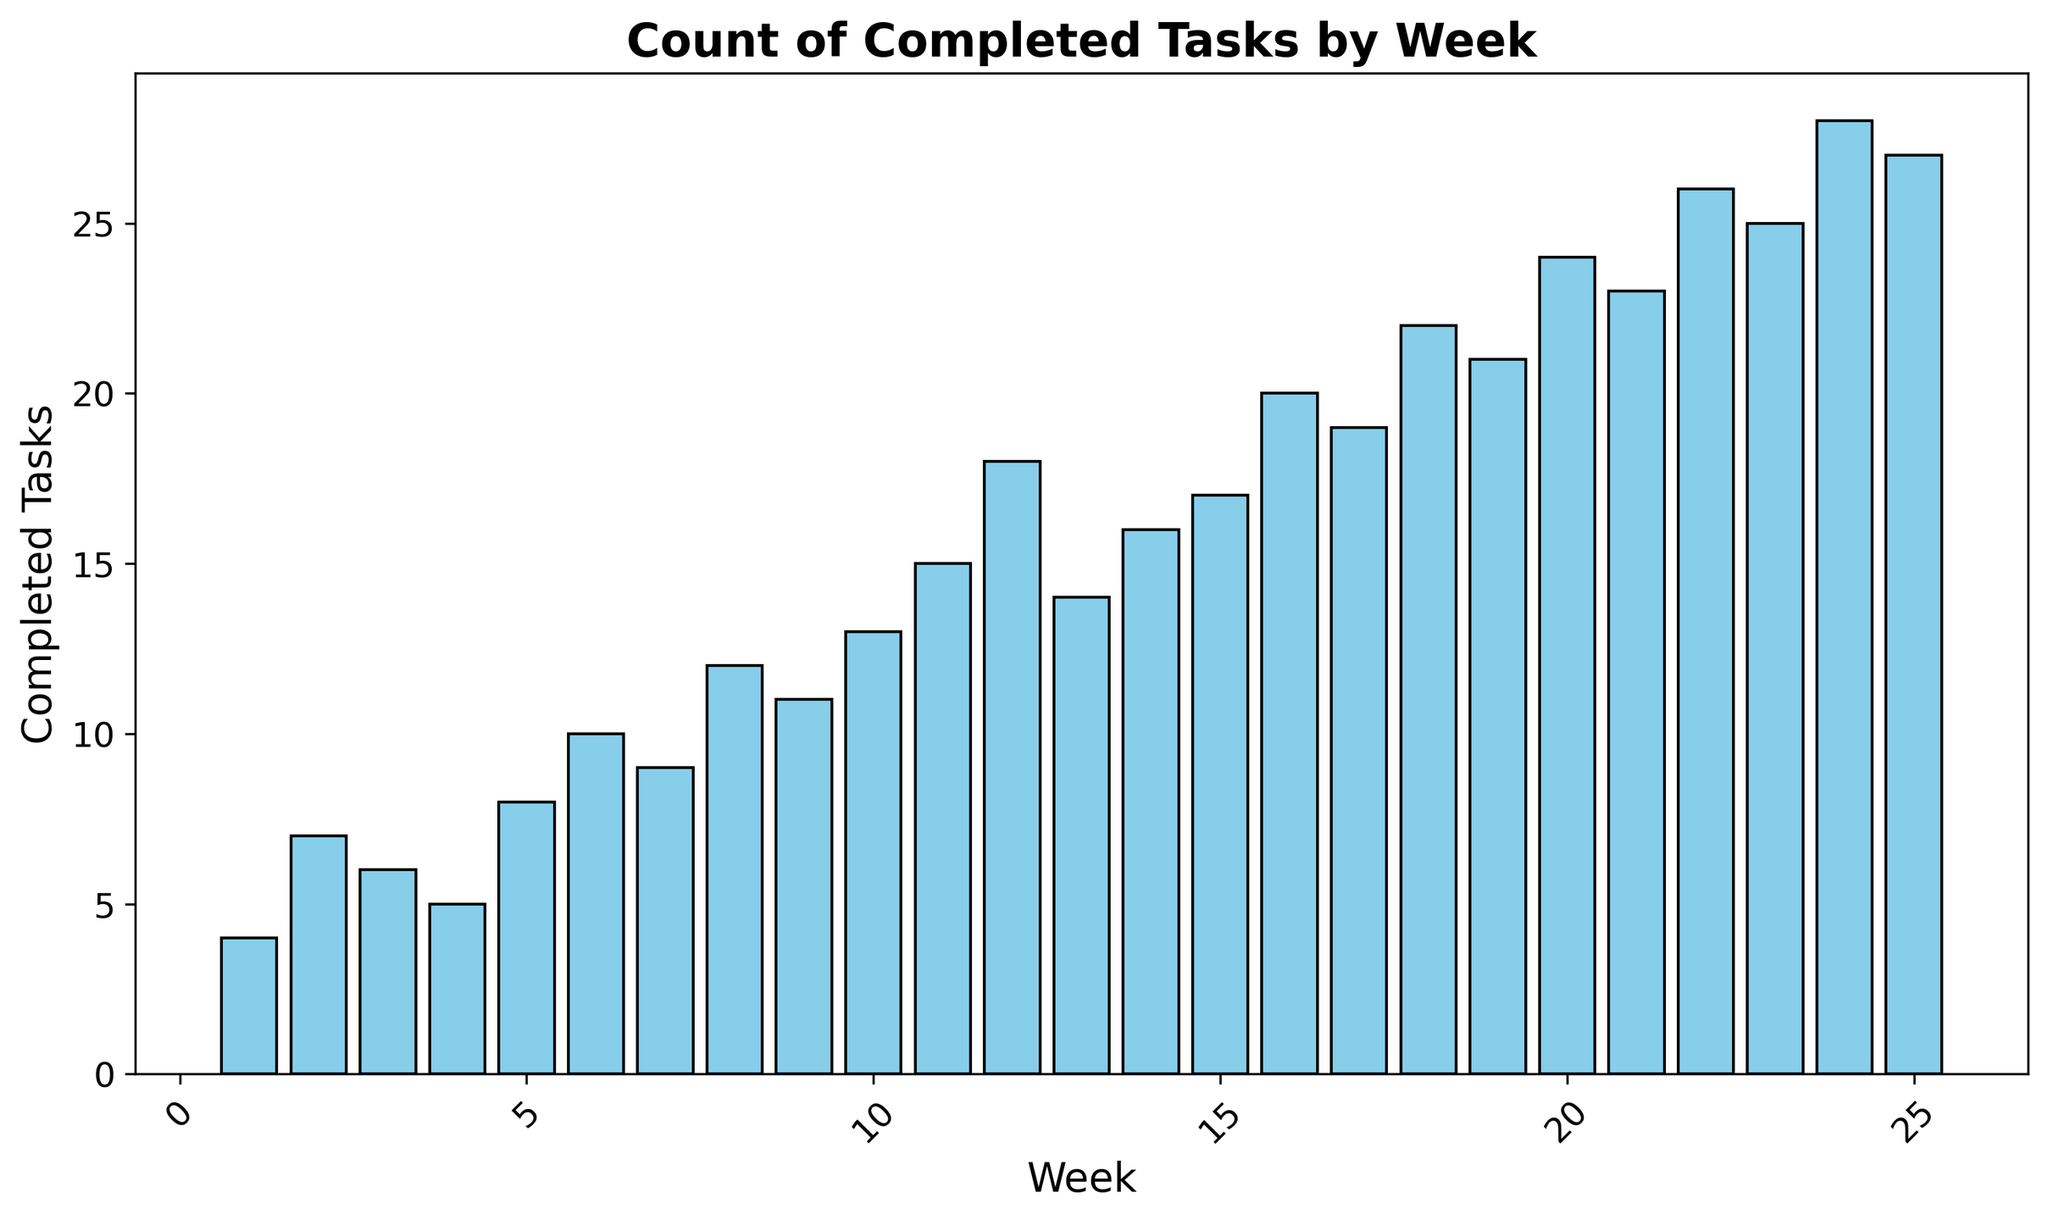What's the average number of completed tasks per week? To find the average number of completed tasks per week, sum up all the values in the "completed_tasks" column and then divide by the number of weeks. The sum is \(4+7+6+5+8+10+9+12+11+13+15+18+14+16+17+20+19+22+21+24+23+26+25+28+27 = 380\). The number of weeks is 25, so the average is \(380/25 = 15.2\).
Answer: 15.2 In which week were the maximum number of tasks completed? By examining the heights of the bars in the histogram, we can see that the highest bar corresponds to week 24 with 28 completed tasks.
Answer: Week 24 How many weeks had less than 10 completed tasks? By identifying the bars that are shorter than the height representing 10 tasks, we see weeks 1, 2, 3, 4, 5, 6, and 7 had less than 10 tasks completed. Counting these bars, there are 7 weeks.
Answer: 7 What is the total number of completed tasks for the first 10 weeks? Add up the number of completed tasks from week 1 to week 10: \(4+7+6+5+8+10+9+12+11+13 = 85\).
Answer: 85 Which week exhibited the most significant increase in completed tasks compared to the previous week? To determine the week with the highest increase, calculate the difference in completed tasks between consecutive weeks and identify the maximum value. Week 18 has the most significant increase with 22 completed tasks compared to 19 in week 17, an increase of \(22-19 = 3\). However, after evaluating each change, week 24 shows the largest increment of \(28 - 25 = 3\) compared to week 23.
Answer: Week 24 Is there a week where the number of completed tasks remained the same as the previous week? By analyzing the bars, no two consecutive weeks have the same number of completed tasks as each bar height is unique.
Answer: No What proportion of the total completed tasks were accomplished by week 12? Sum the number of completed tasks from week 1 to week 12, which is \(4 + 7 + 6 + 5 + 8 + 10 + 9 + 12 + 11 + 13 + 15 + 18 = 118\). The total number of tasks completed over all weeks is 380. Thus, the proportion is \(118/380 = 0.31\).
Answer: 0.31 Which week has the closest number of completed tasks to the average? The average number of completed tasks is 15.2. The week with 15 tasks (week 11) is closest to this average.
Answer: Week 11 Is there a visible trend in the number of completed tasks over time? By observing the histogram, one can perceive an overall upward trend in the number of completed tasks, as bars tend to get taller as the weeks progress.
Answer: Yes What is the median number of completed tasks? Since there are 25 weeks, the median corresponds to the 13th value in the sorted list of completed tasks. Sorting the completed tasks: \(4, 5, 6, 7, 8, 9, 10, 11, 12, 13, 14, 15, 16, 17, 18, 19, 20, 21, 22, 23, 24, 25, 26, 27, 28\). The 13th value is 16.
Answer: 16 